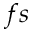Convert formula to latex. <formula><loc_0><loc_0><loc_500><loc_500>f s</formula> 